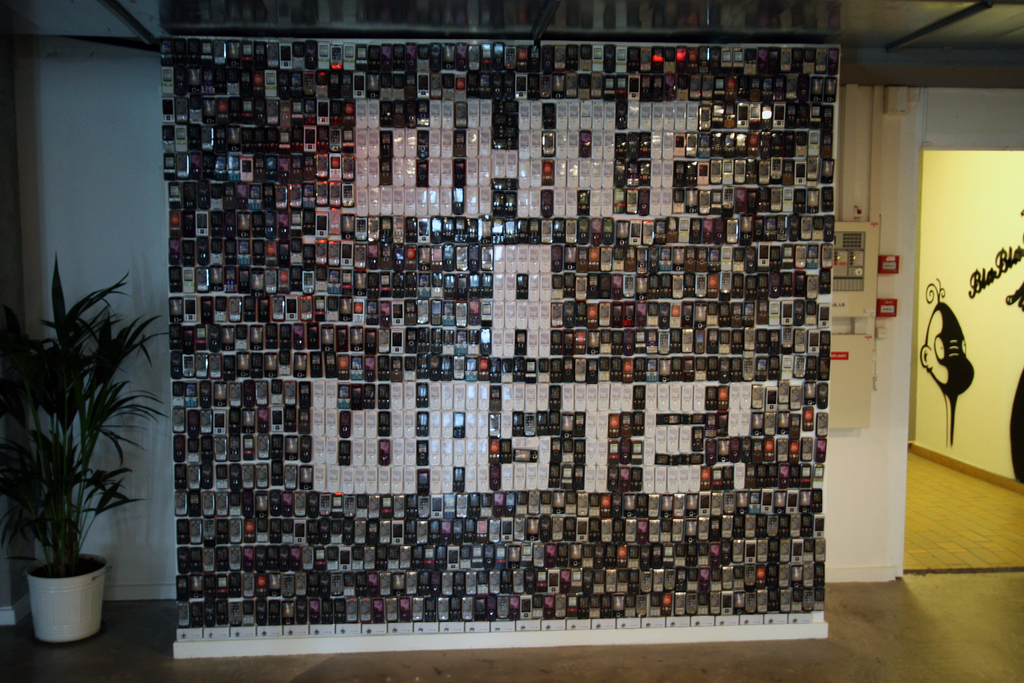What might be the significance of using black and white photos to create the image of a bird? The monochromatic photos may have been chosen to emphasize the theme of recollection and history, as black and white imagery is often associated with the past. By assembling these photos into the shape of a bird, a creature known for its freedom and the ability to transcend boundaries, the artist could be making a statement about the contrast between the permanence of our recorded history and the fleeting nature of life. The bird's silhouette might represent the idea of memories taking flight, capturing the essence of freedom, even within the confines of structured, physical forms. 